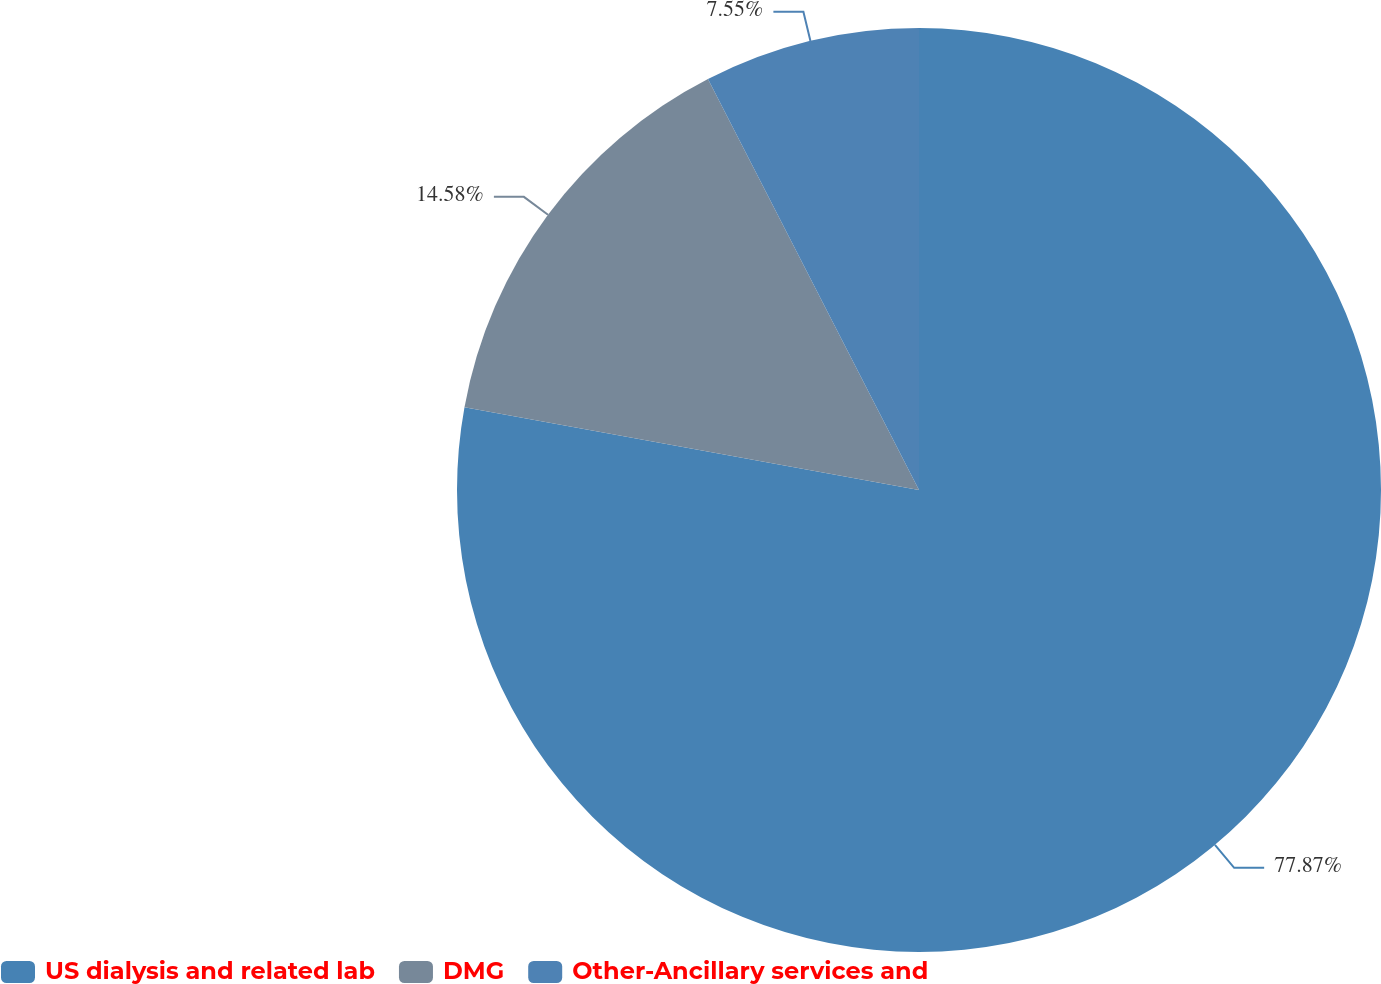Convert chart. <chart><loc_0><loc_0><loc_500><loc_500><pie_chart><fcel>US dialysis and related lab<fcel>DMG<fcel>Other-Ancillary services and<nl><fcel>77.87%<fcel>14.58%<fcel>7.55%<nl></chart> 